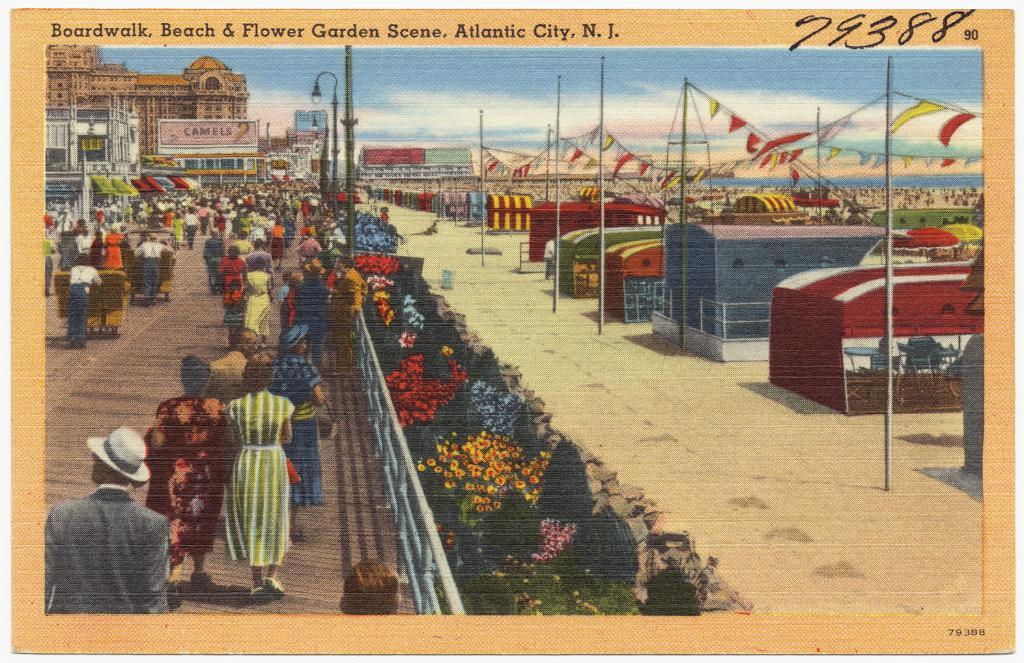<image>
Render a clear and concise summary of the photo. A postcard showing a beach scene and titled Boardwalk, Beach & Flower Garden Scene. 